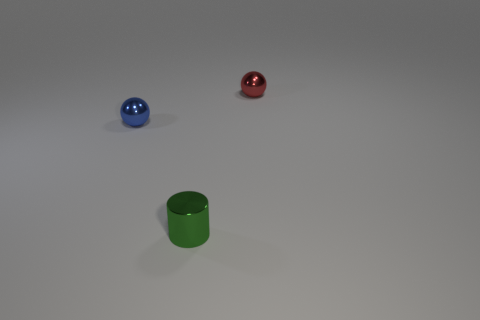Add 2 blue metal spheres. How many objects exist? 5 Subtract all spheres. How many objects are left? 1 Subtract all red metal things. Subtract all small metallic cylinders. How many objects are left? 1 Add 2 tiny cylinders. How many tiny cylinders are left? 3 Add 3 blue objects. How many blue objects exist? 4 Subtract 0 blue cylinders. How many objects are left? 3 